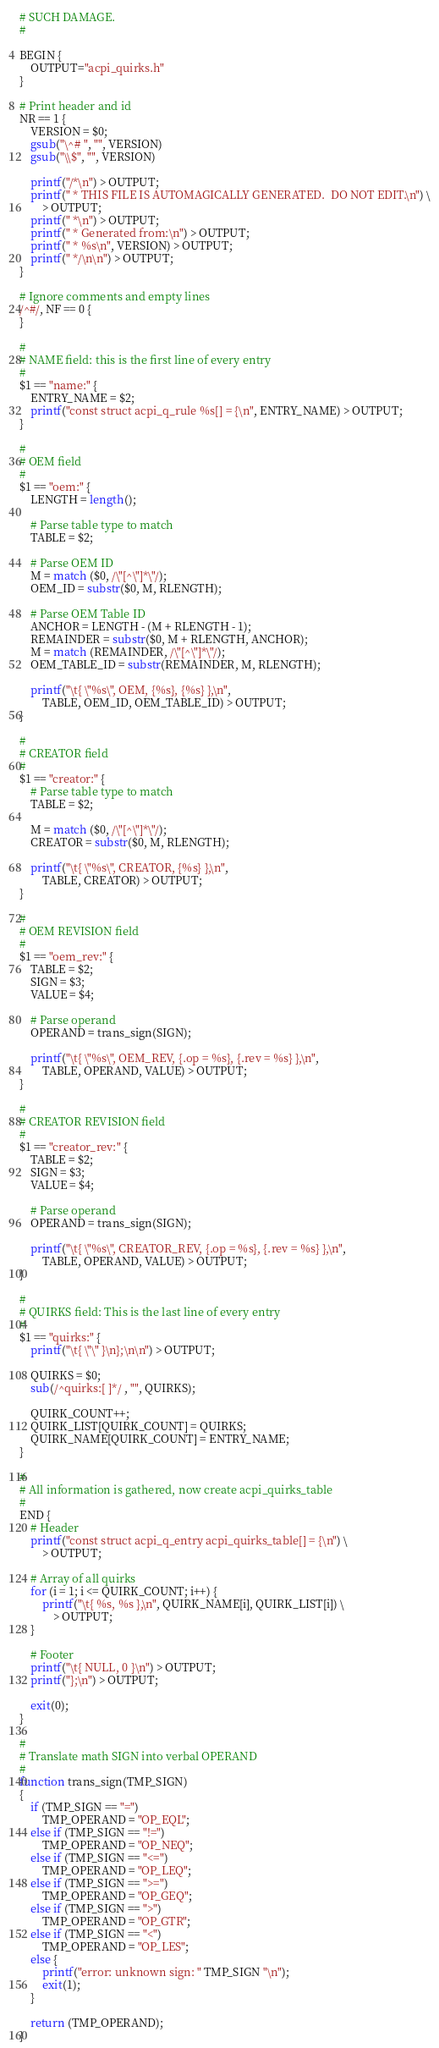Convert code to text. <code><loc_0><loc_0><loc_500><loc_500><_Awk_># SUCH DAMAGE.
#

BEGIN {
	OUTPUT="acpi_quirks.h"
}

# Print header and id
NR == 1 {
	VERSION = $0;
	gsub("\^# ", "", VERSION)
	gsub("\\$", "", VERSION)

	printf("/*\n") > OUTPUT;
	printf(" * THIS FILE IS AUTOMAGICALLY GENERATED.  DO NOT EDIT.\n") \
	    > OUTPUT;
	printf(" *\n") > OUTPUT;
	printf(" * Generated from:\n") > OUTPUT;
	printf(" * %s\n", VERSION) > OUTPUT;
	printf(" */\n\n") > OUTPUT;
}

# Ignore comments and empty lines
/^#/, NF == 0 {
}

#
# NAME field: this is the first line of every entry
#
$1 == "name:" {
	ENTRY_NAME = $2;
	printf("const struct acpi_q_rule %s[] = {\n", ENTRY_NAME) > OUTPUT;
}

#
# OEM field
#
$1 == "oem:" {
	LENGTH = length();

	# Parse table type to match
	TABLE = $2;

	# Parse OEM ID
	M = match ($0, /\"[^\"]*\"/);
	OEM_ID = substr($0, M, RLENGTH);

	# Parse OEM Table ID
	ANCHOR = LENGTH - (M + RLENGTH - 1);
	REMAINDER = substr($0, M + RLENGTH, ANCHOR);
	M = match (REMAINDER, /\"[^\"]*\"/);
	OEM_TABLE_ID = substr(REMAINDER, M, RLENGTH);

	printf("\t{ \"%s\", OEM, {%s}, {%s} },\n",
	    TABLE, OEM_ID, OEM_TABLE_ID) > OUTPUT;
}

#
# CREATOR field
#
$1 == "creator:" {
	# Parse table type to match
	TABLE = $2;

	M = match ($0, /\"[^\"]*\"/);
	CREATOR = substr($0, M, RLENGTH);

	printf("\t{ \"%s\", CREATOR, {%s} },\n",
	    TABLE, CREATOR) > OUTPUT;
}

#
# OEM REVISION field
#
$1 == "oem_rev:" {
	TABLE = $2;
	SIGN = $3;
	VALUE = $4;

	# Parse operand
	OPERAND = trans_sign(SIGN);

	printf("\t{ \"%s\", OEM_REV, {.op = %s}, {.rev = %s} },\n",
	    TABLE, OPERAND, VALUE) > OUTPUT;
}

#
# CREATOR REVISION field
#
$1 == "creator_rev:" {
	TABLE = $2;
	SIGN = $3;
	VALUE = $4;

	# Parse operand
	OPERAND = trans_sign(SIGN);

	printf("\t{ \"%s\", CREATOR_REV, {.op = %s}, {.rev = %s} },\n",
	    TABLE, OPERAND, VALUE) > OUTPUT;
}

#
# QUIRKS field: This is the last line of every entry
#
$1 == "quirks:" {
	printf("\t{ \"\" }\n};\n\n") > OUTPUT;

	QUIRKS = $0;
	sub(/^quirks:[ ]*/ , "", QUIRKS);

	QUIRK_COUNT++;
	QUIRK_LIST[QUIRK_COUNT] = QUIRKS;
	QUIRK_NAME[QUIRK_COUNT] = ENTRY_NAME;
}

#
# All information is gathered, now create acpi_quirks_table
#
END {
	# Header
	printf("const struct acpi_q_entry acpi_quirks_table[] = {\n") \
	    > OUTPUT;

	# Array of all quirks
	for (i = 1; i <= QUIRK_COUNT; i++) {
		printf("\t{ %s, %s },\n", QUIRK_NAME[i], QUIRK_LIST[i]) \
		    > OUTPUT;
	}

	# Footer
	printf("\t{ NULL, 0 }\n") > OUTPUT;
	printf("};\n") > OUTPUT;

	exit(0);
}

#
# Translate math SIGN into verbal OPERAND
#
function trans_sign(TMP_SIGN)
{
	if (TMP_SIGN == "=")
		TMP_OPERAND = "OP_EQL";
	else if (TMP_SIGN == "!=")
		TMP_OPERAND = "OP_NEQ";
	else if (TMP_SIGN == "<=")
		TMP_OPERAND = "OP_LEQ";
	else if (TMP_SIGN == ">=")
		TMP_OPERAND = "OP_GEQ";
	else if (TMP_SIGN == ">")
		TMP_OPERAND = "OP_GTR";
	else if (TMP_SIGN == "<")
		TMP_OPERAND = "OP_LES";
	else {
		printf("error: unknown sign: " TMP_SIGN "\n");
		exit(1);
	}

	return (TMP_OPERAND);
}
</code> 